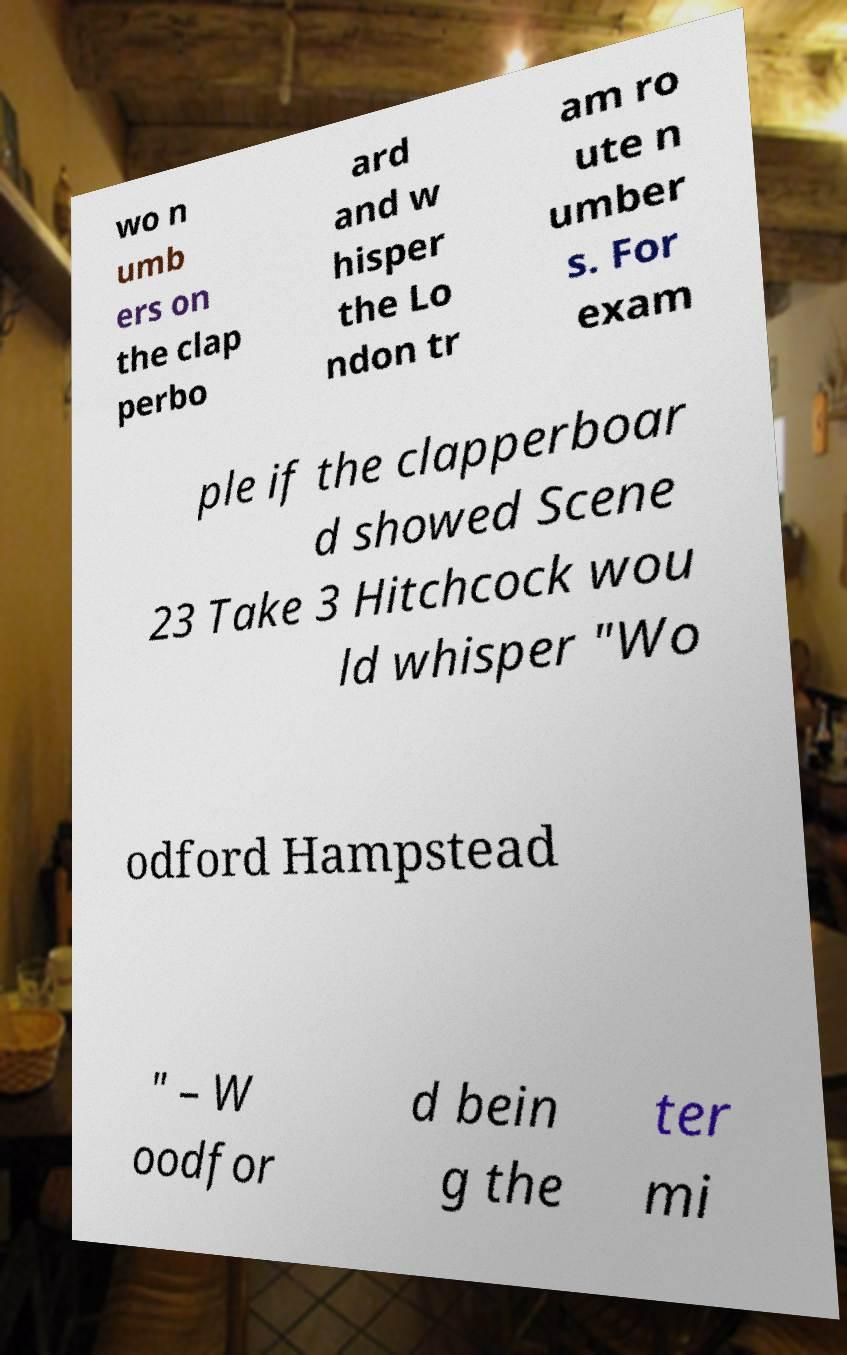Could you assist in decoding the text presented in this image and type it out clearly? wo n umb ers on the clap perbo ard and w hisper the Lo ndon tr am ro ute n umber s. For exam ple if the clapperboar d showed Scene 23 Take 3 Hitchcock wou ld whisper "Wo odford Hampstead " – W oodfor d bein g the ter mi 